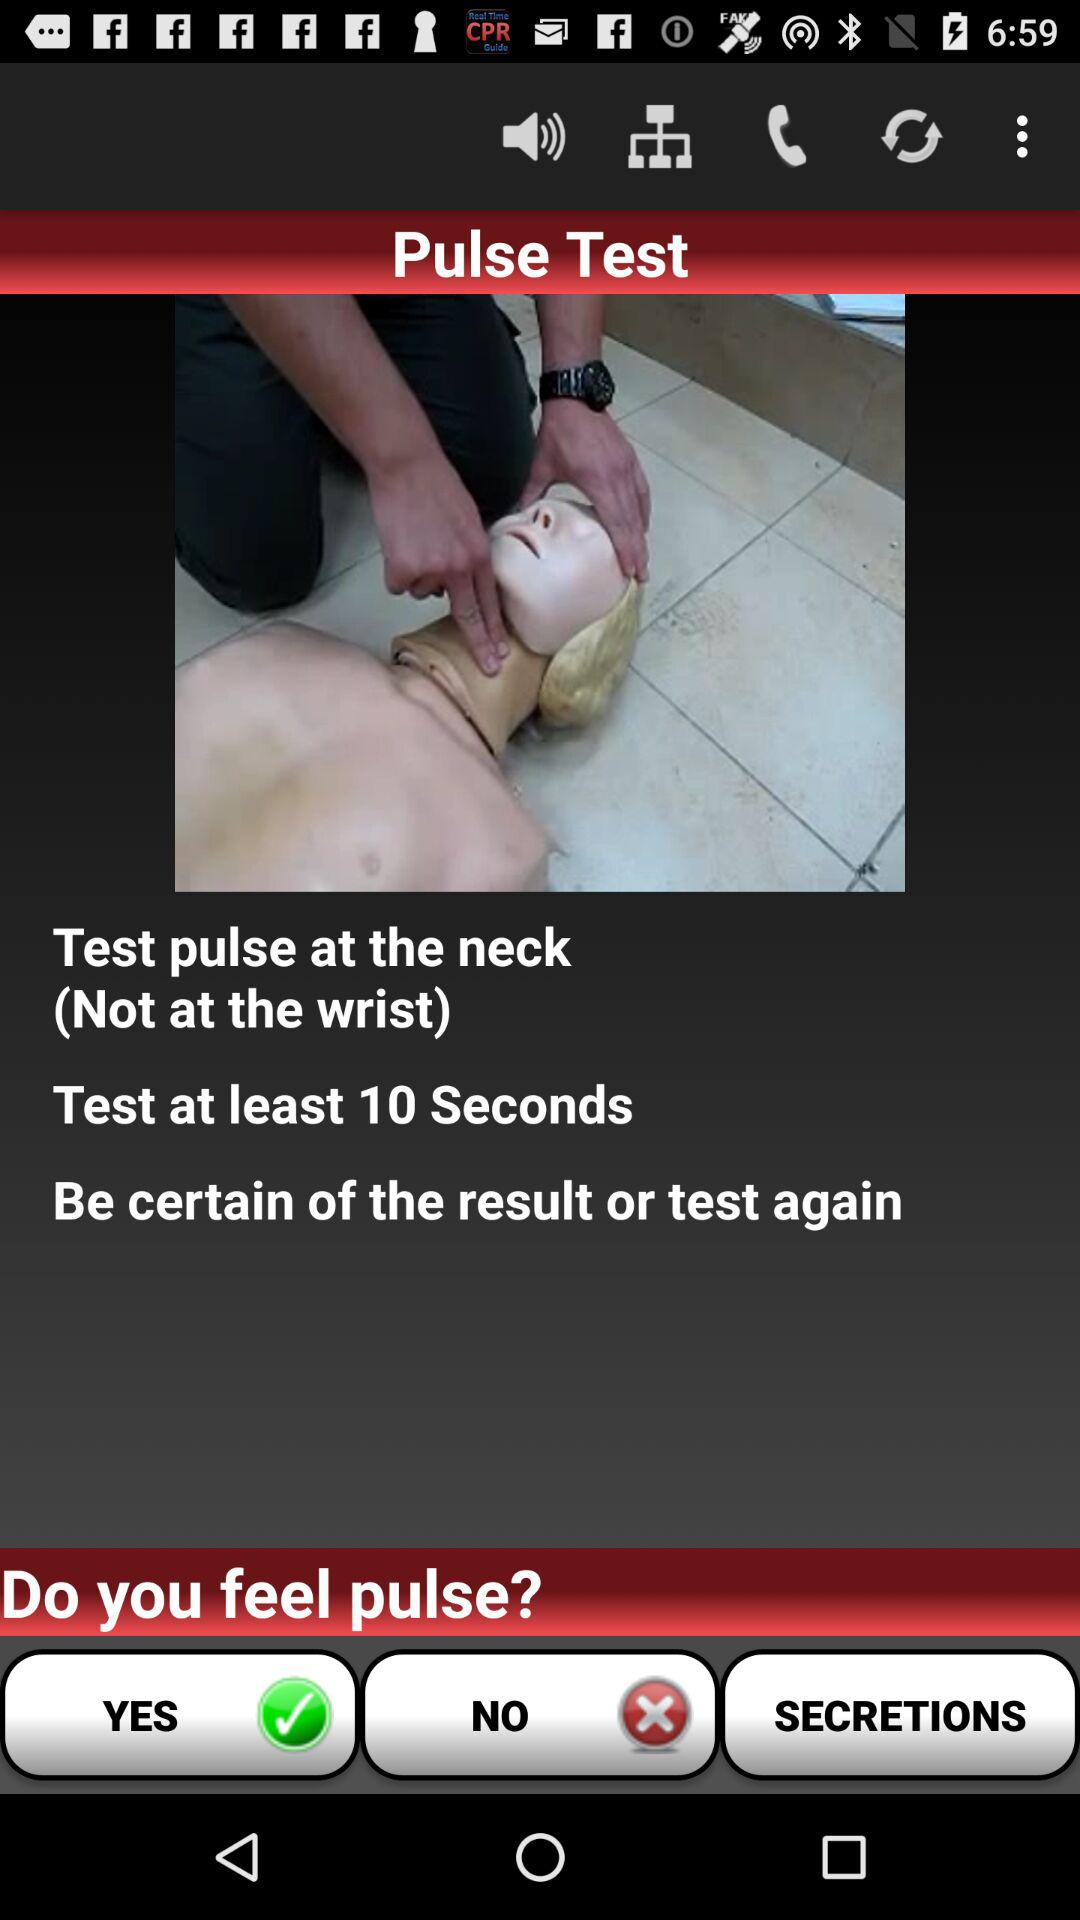What's the least number of seconds to test the pulse? The least number of seconds to test the pulse is 10. 